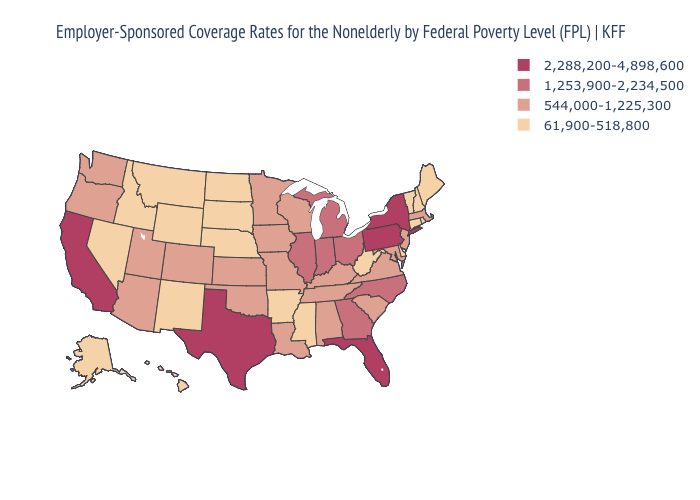How many symbols are there in the legend?
Quick response, please. 4. Among the states that border Wyoming , which have the highest value?
Be succinct. Colorado, Utah. Which states have the lowest value in the Northeast?
Quick response, please. Connecticut, Maine, New Hampshire, Rhode Island, Vermont. What is the highest value in the USA?
Answer briefly. 2,288,200-4,898,600. What is the lowest value in the West?
Write a very short answer. 61,900-518,800. What is the value of New Hampshire?
Quick response, please. 61,900-518,800. Does the first symbol in the legend represent the smallest category?
Answer briefly. No. Name the states that have a value in the range 544,000-1,225,300?
Be succinct. Alabama, Arizona, Colorado, Iowa, Kansas, Kentucky, Louisiana, Maryland, Massachusetts, Minnesota, Missouri, New Jersey, Oklahoma, Oregon, South Carolina, Tennessee, Utah, Virginia, Washington, Wisconsin. Name the states that have a value in the range 61,900-518,800?
Write a very short answer. Alaska, Arkansas, Connecticut, Delaware, Hawaii, Idaho, Maine, Mississippi, Montana, Nebraska, Nevada, New Hampshire, New Mexico, North Dakota, Rhode Island, South Dakota, Vermont, West Virginia, Wyoming. Among the states that border Delaware , which have the highest value?
Be succinct. Pennsylvania. Does Illinois have a lower value than New York?
Give a very brief answer. Yes. What is the value of Texas?
Quick response, please. 2,288,200-4,898,600. Which states have the lowest value in the USA?
Write a very short answer. Alaska, Arkansas, Connecticut, Delaware, Hawaii, Idaho, Maine, Mississippi, Montana, Nebraska, Nevada, New Hampshire, New Mexico, North Dakota, Rhode Island, South Dakota, Vermont, West Virginia, Wyoming. Which states hav the highest value in the South?
Keep it brief. Florida, Texas. What is the highest value in states that border North Carolina?
Write a very short answer. 1,253,900-2,234,500. 